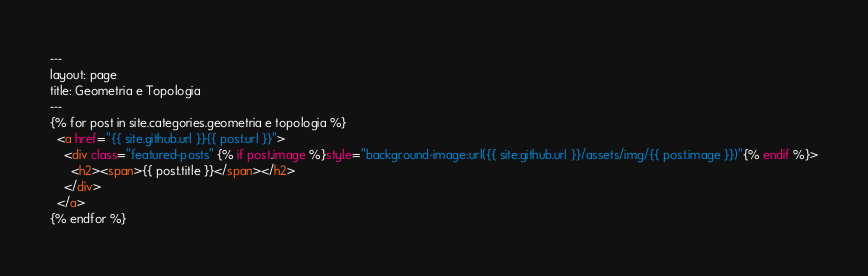<code> <loc_0><loc_0><loc_500><loc_500><_HTML_>---
layout: page
title: Geometria e Topologia
---
{% for post in site.categories.geometria e topologia %}
  <a href="{{ site.github.url }}{{ post.url }}">
    <div class="featured-posts" {% if post.image %}style="background-image:url({{ site.github.url }}/assets/img/{{ post.image }})"{% endif %}>
      <h2><span>{{ post.title }}</span></h2>
    </div>
  </a>
{% endfor %}
</code> 